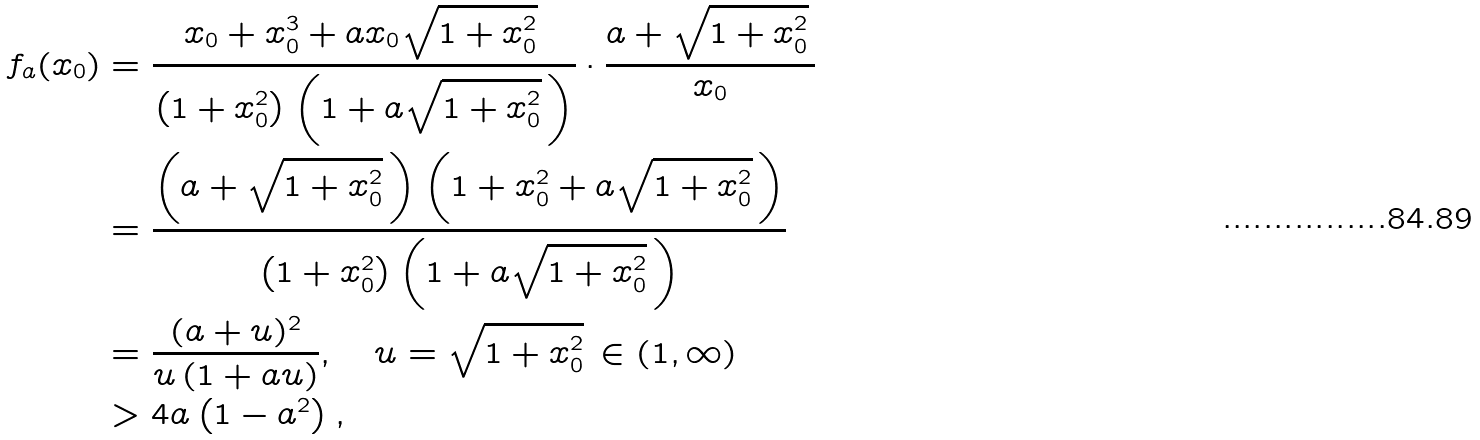<formula> <loc_0><loc_0><loc_500><loc_500>f _ { a } ( x _ { 0 } ) & = \frac { x _ { 0 } + x _ { 0 } ^ { 3 } + a x _ { 0 } \sqrt { 1 + x _ { 0 } ^ { 2 } } \, } { \left ( 1 + x _ { 0 } ^ { 2 } \right ) \left ( 1 + a \sqrt { 1 + x _ { 0 } ^ { 2 } } \, \right ) } \cdot \frac { a + \sqrt { 1 + x _ { 0 } ^ { 2 } } \, } { x _ { 0 } } \\ & = \frac { \left ( a + \sqrt { 1 + x _ { 0 } ^ { 2 } } \, \right ) \left ( 1 + x _ { 0 } ^ { 2 } + a \sqrt { 1 + x _ { 0 } ^ { 2 } } \, \right ) } { \left ( 1 + x _ { 0 } ^ { 2 } \right ) \left ( 1 + a \sqrt { 1 + x _ { 0 } ^ { 2 } } \, \right ) } \\ & = \frac { ( a + u ) ^ { 2 } } { u \left ( 1 + a u \right ) } , \quad u = \sqrt { 1 + x _ { 0 } ^ { 2 } } \, \in ( 1 , \infty ) \\ & > 4 a \left ( 1 - a ^ { 2 } \right ) ,</formula> 